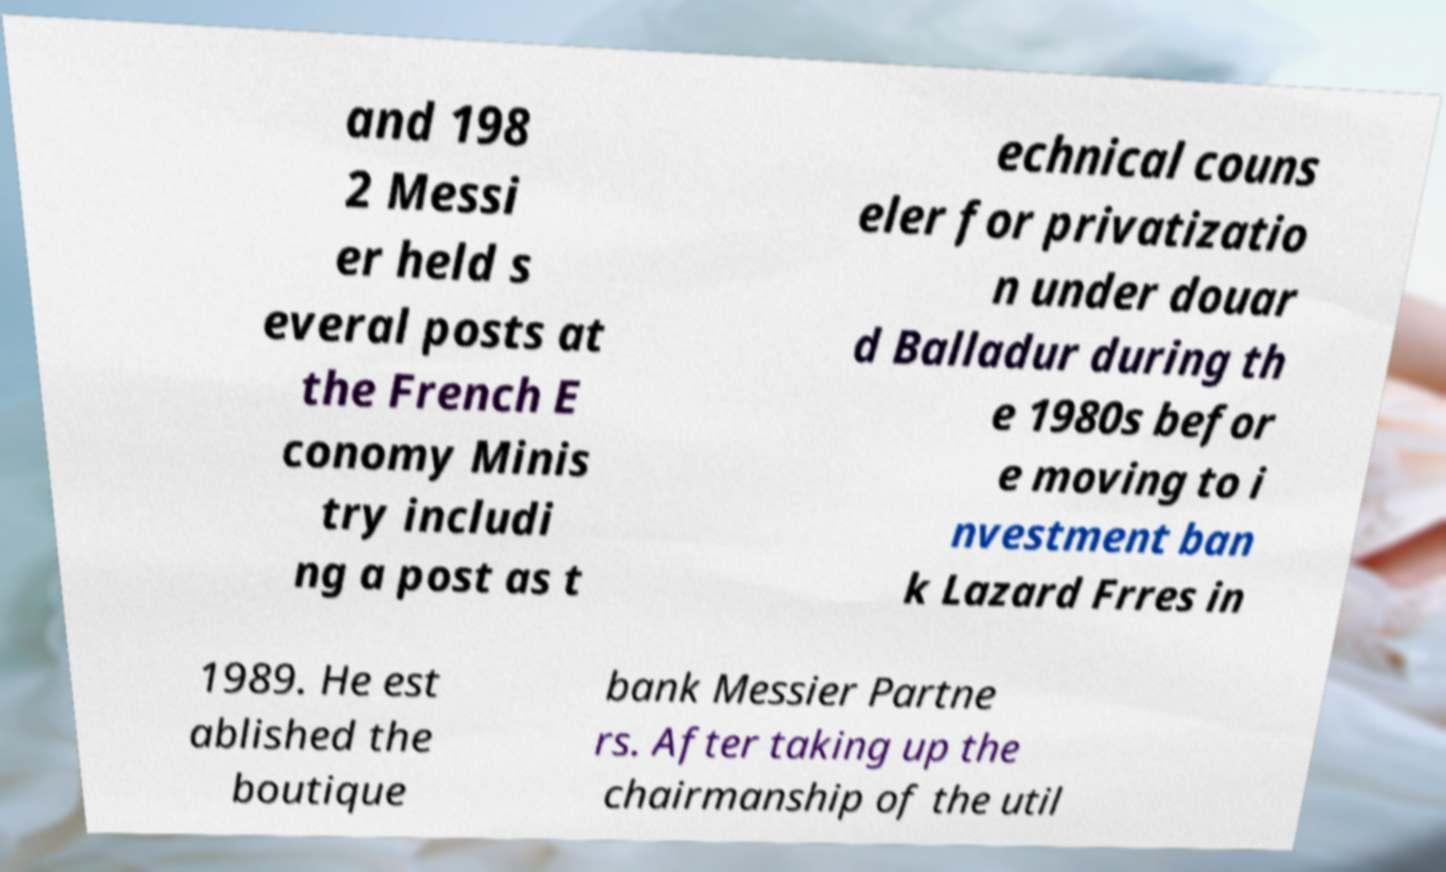Please read and relay the text visible in this image. What does it say? and 198 2 Messi er held s everal posts at the French E conomy Minis try includi ng a post as t echnical couns eler for privatizatio n under douar d Balladur during th e 1980s befor e moving to i nvestment ban k Lazard Frres in 1989. He est ablished the boutique bank Messier Partne rs. After taking up the chairmanship of the util 